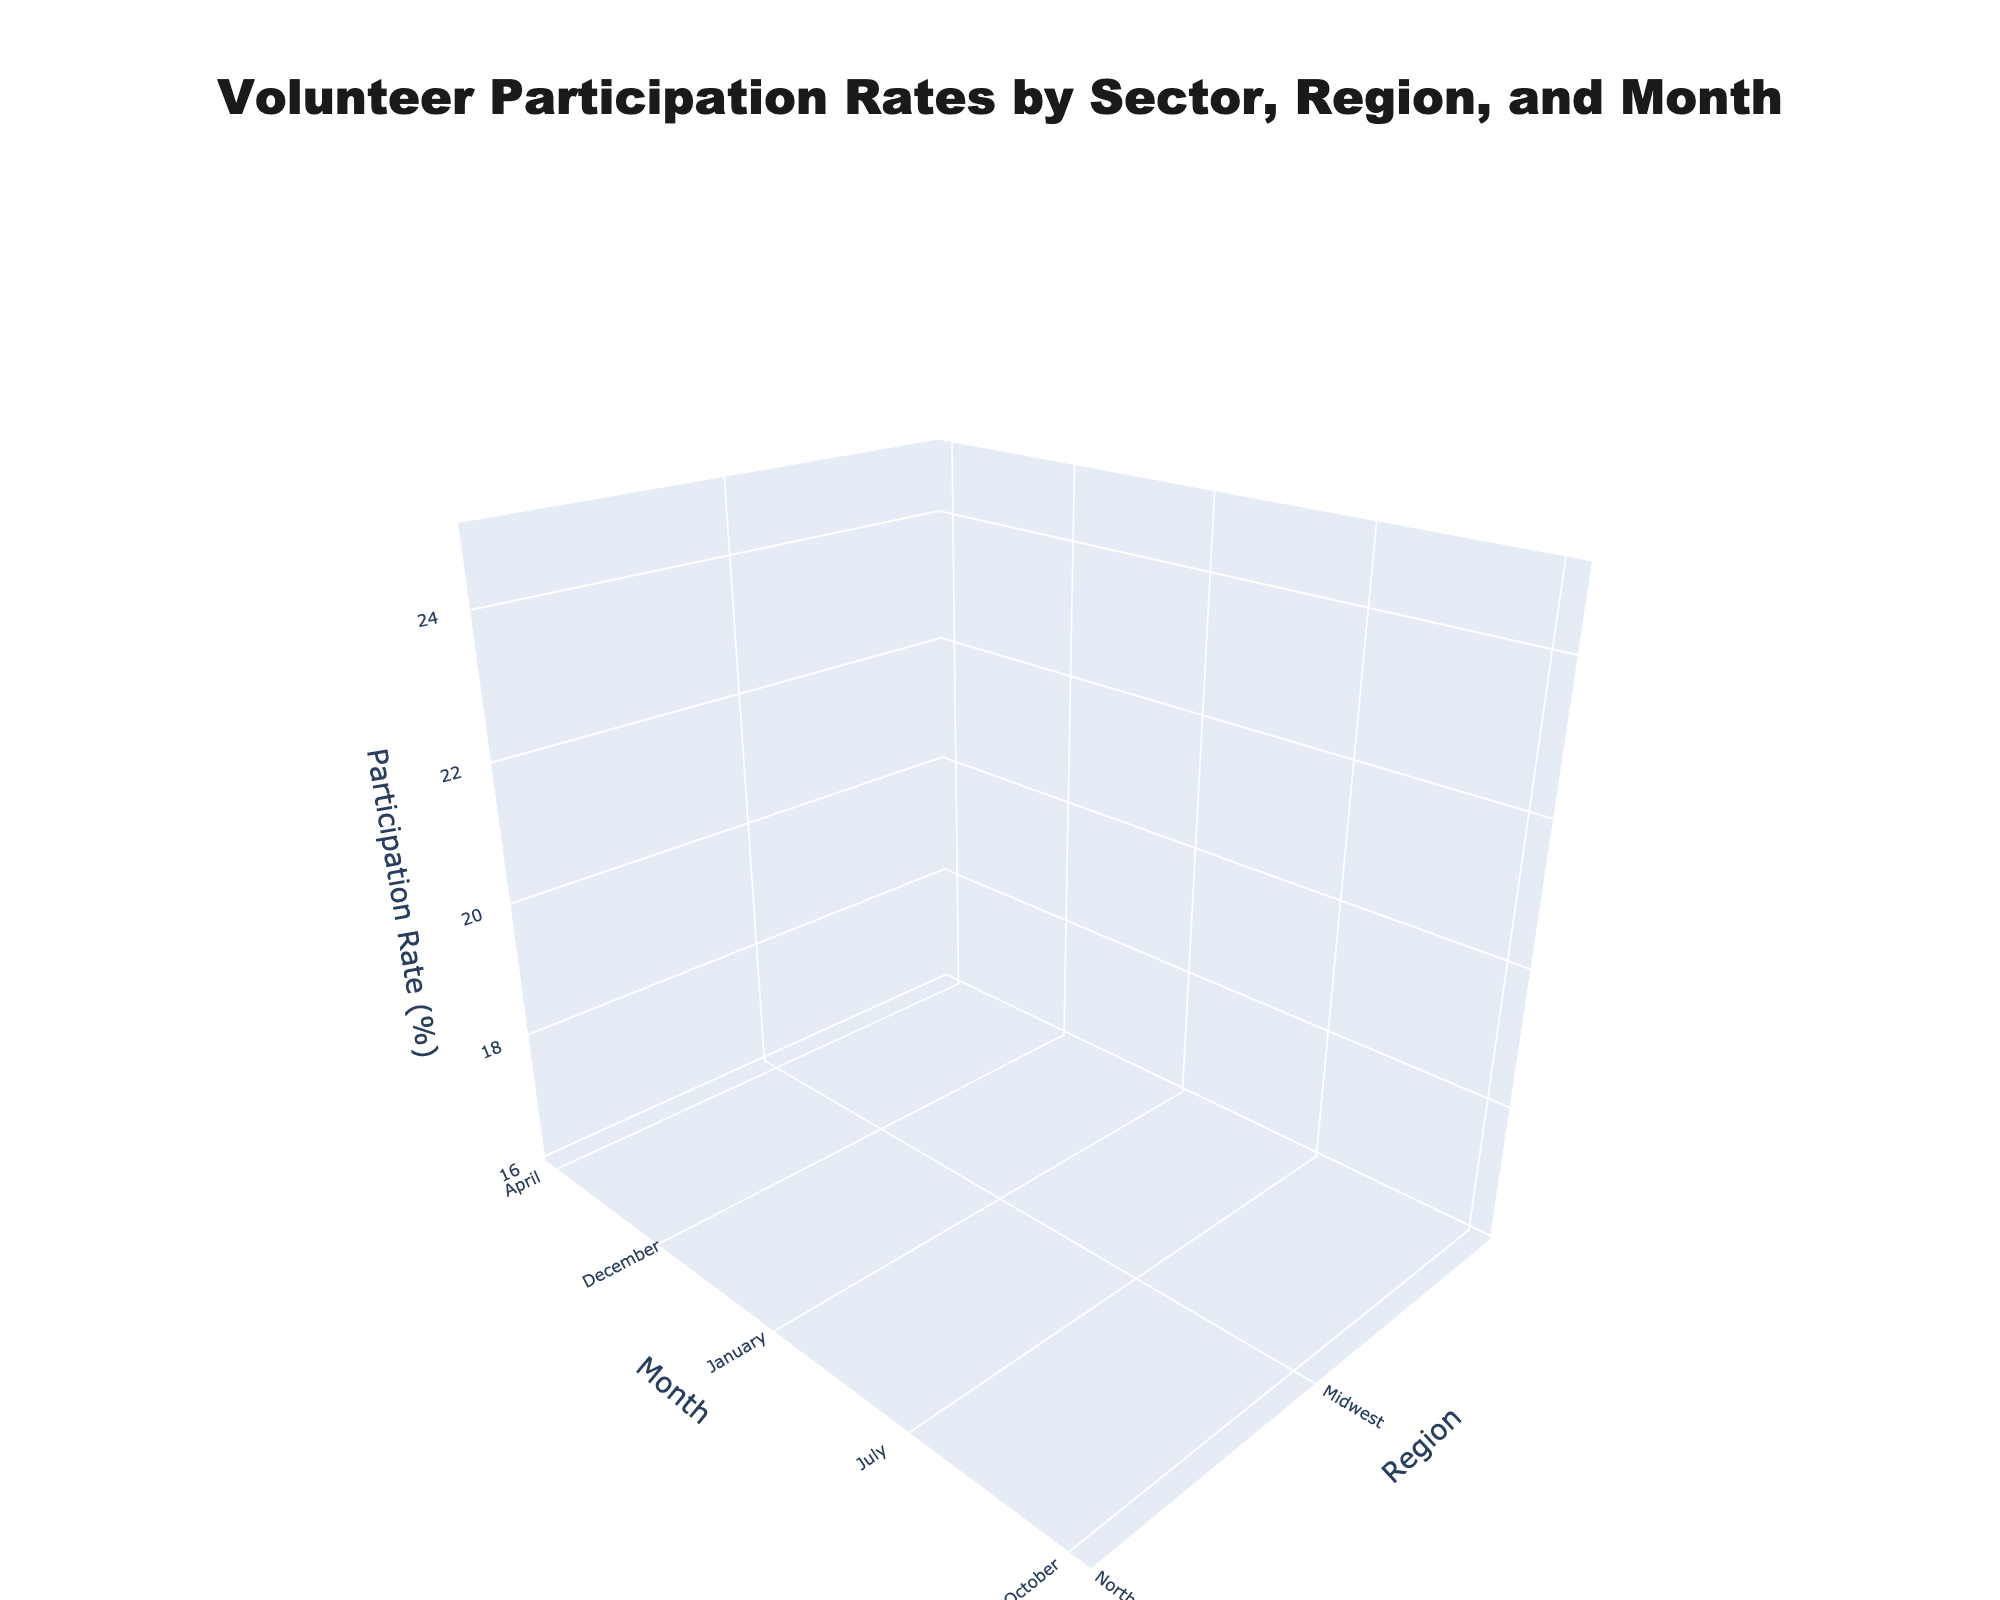What is the title of the figure? The title is usually found at the top of the figure. By reading the text in that location, you can determine the title.
Answer: Volunteer Participation Rates by Sector, Region, and Month What are the axis titles in the figure? The axis titles are found next to each axis, indicating what data each axis represents.
Answer: Region, Month, Participation Rate (%) Which region has the highest participation rate in April for the Social Services sector? By locating the month of April on the y-axis and then following the surface corresponding to the Social Services sector, you can see which region has the peak value.
Answer: West How does volunteer participation in the Environmental sector in the Northeast region change from January to July? Follow the surface corresponding to the Environmental sector and observe the z-values for the Northeast region from January to July. Note the participation rates at these points.
Answer: It increases Which sector shows the largest variation in volunteer participation rates in the Northeast region throughout the year? Observe the surfaces corresponding to the different sectors over the Northeast region and identify which sector's surface shows the largest range from its lowest to highest values.
Answer: Environmental Compare the participation rates in the Healthcare sector between the Midwest region and the South region in July. Locate the month of July on the y-axis, then compare the surface heights (participation rates) for the Healthcare sector for both the Midwest and South regions.
Answer: Midwest is higher What's the difference in participation rates for the Environmental sector in the Northeast between April and October? Follow the surface for the Environmental sector and note the participation rates in April and October for the Northeast region. Subtract the October rate from the April rate.
Answer: 3.9% Describe the trend in volunteer participation for the Education sector in the South region over the months presented. Follow the surface for the Education sector and observe how the z-values change over the different months for the South region.
Answer: It peaks in April and declines toward December Which sector has the lowest participation rate in December across all regions? Find the surfaces for December and observe the lowest point across all regions, then identify which sector that point belongs to.
Answer: Education What's the average participation rate for Social Services across all regions in July? Locate July on the y-axis and find the participation rates for all regions in the Social Services sector. Calculate the average of these values.
Answer: 23.7 